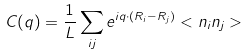Convert formula to latex. <formula><loc_0><loc_0><loc_500><loc_500>C ( { q } ) = \frac { 1 } { L } \sum _ { i j } e ^ { i { q } \cdot ( { R _ { i } - R _ { j } } ) } < n _ { i } n _ { j } ></formula> 